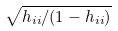Convert formula to latex. <formula><loc_0><loc_0><loc_500><loc_500>\sqrt { h _ { i i } / ( 1 - h _ { i i } ) }</formula> 